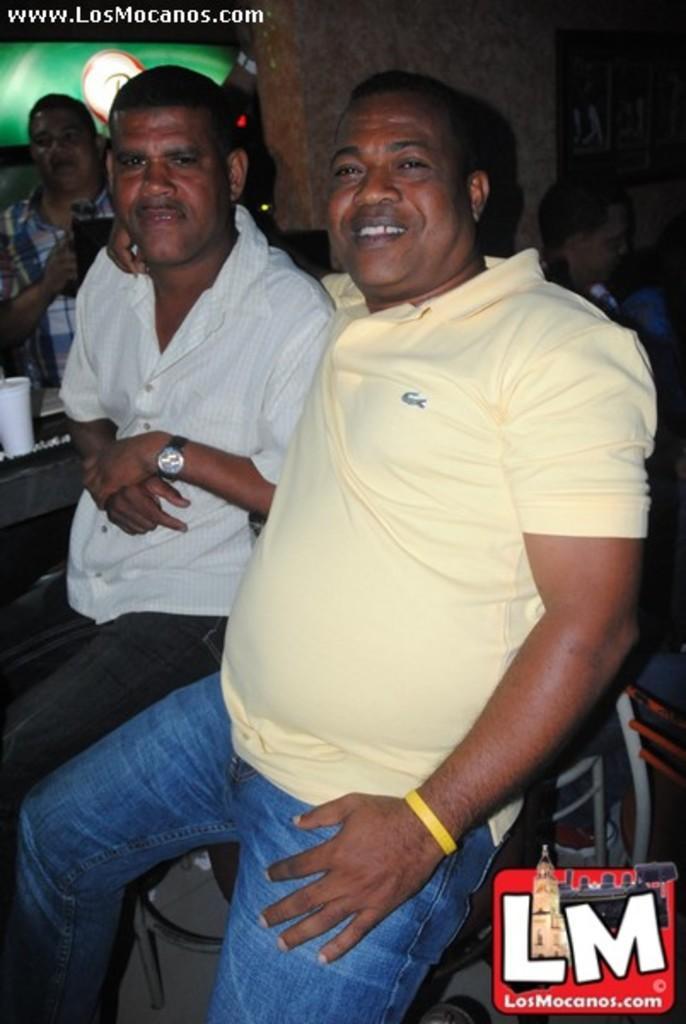Can you describe this image briefly? This 2 persons are highlighted in this picture. This man wore yellow t-shirt and a band. This man wore white shirt and a watch. This man kept his hand on the other man's shoulder. Far there is a person standing. In-front of this person there is a table. A cup is on a table. 